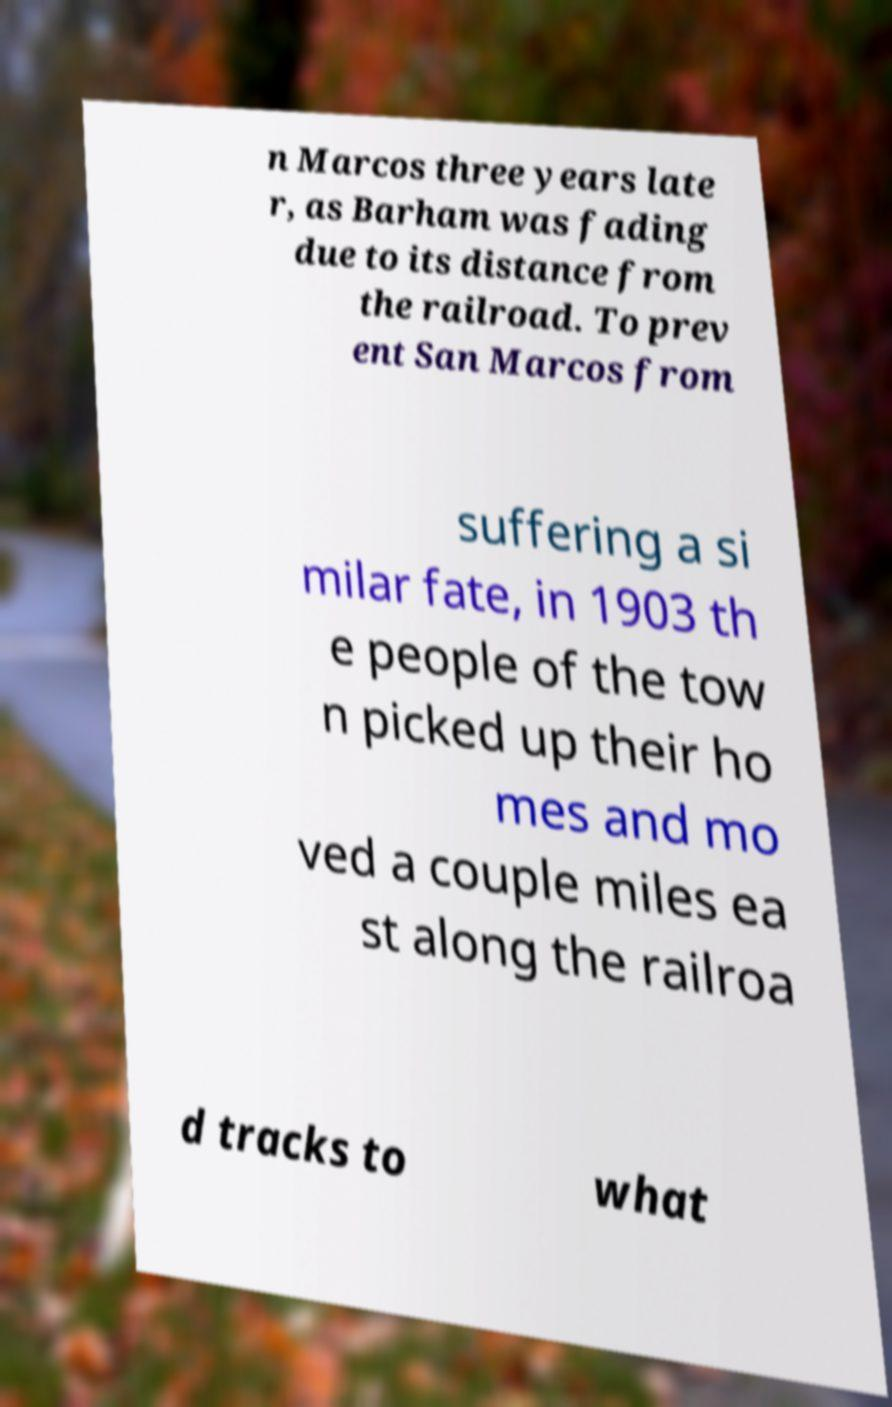Could you assist in decoding the text presented in this image and type it out clearly? n Marcos three years late r, as Barham was fading due to its distance from the railroad. To prev ent San Marcos from suffering a si milar fate, in 1903 th e people of the tow n picked up their ho mes and mo ved a couple miles ea st along the railroa d tracks to what 